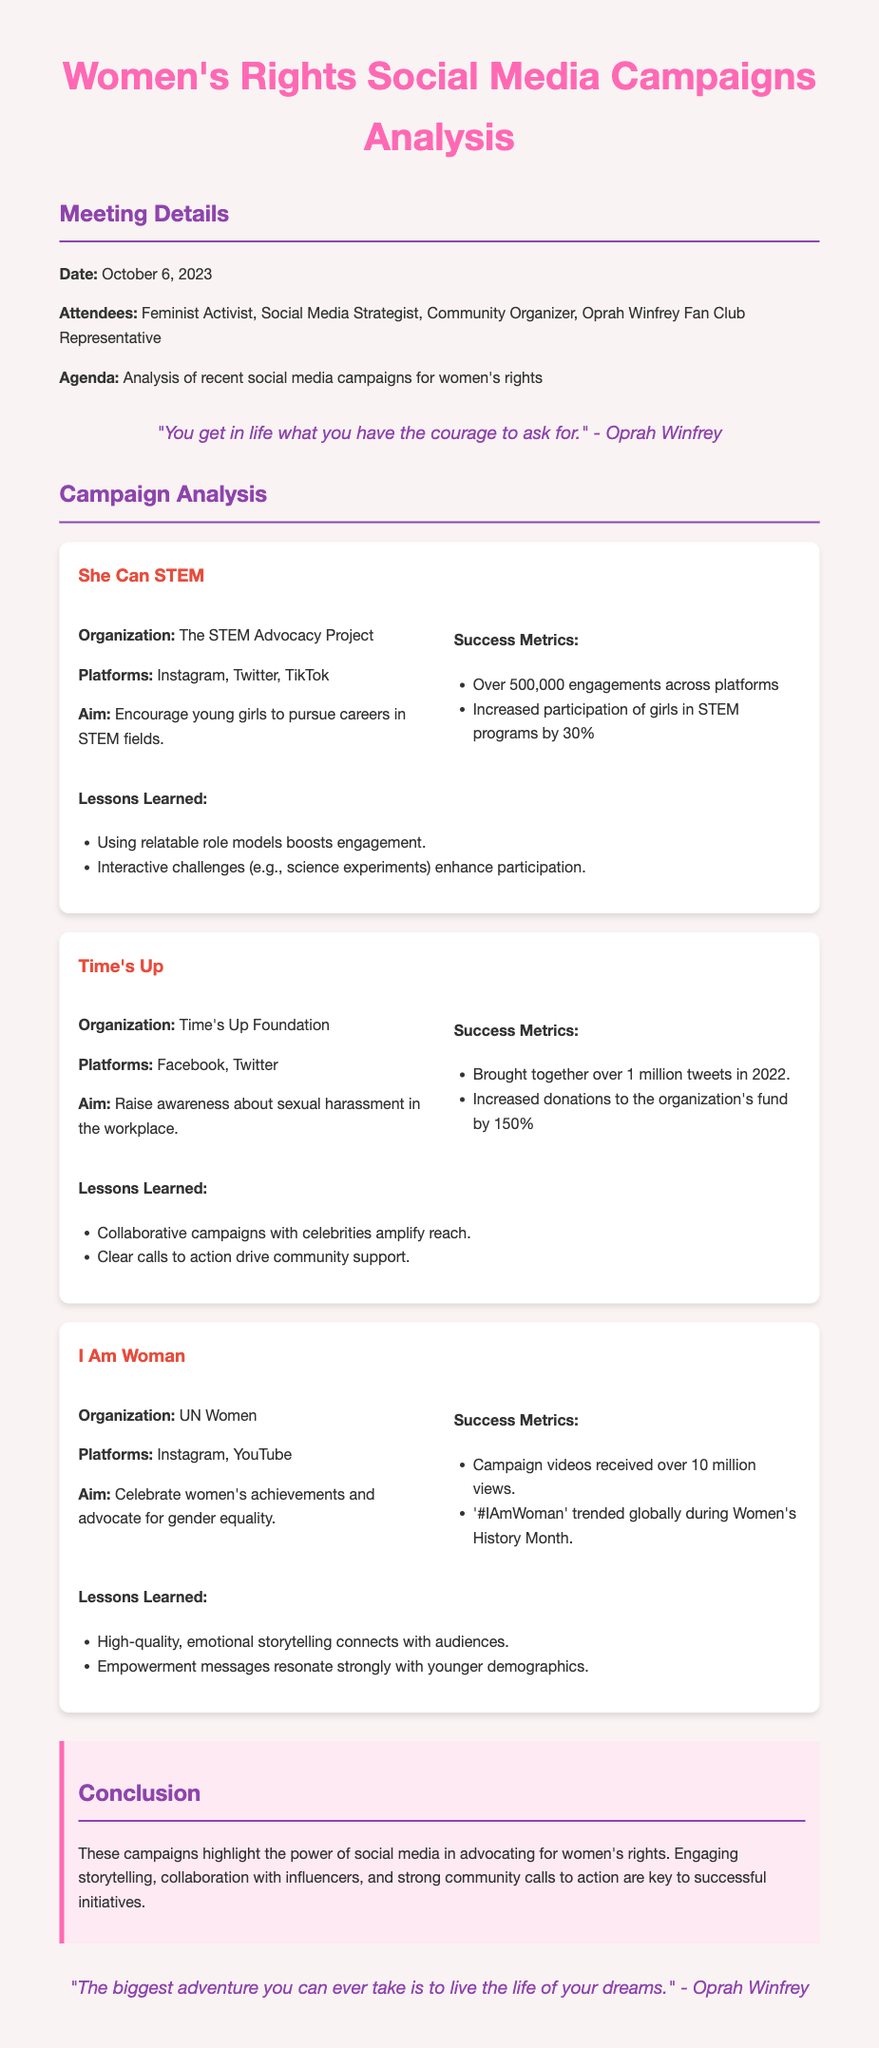What is the date of the meeting? The date of the meeting is specified in the meeting details section.
Answer: October 6, 2023 Who organized the "She Can STEM" campaign? Details about the organization behind the campaign are provided in the campaign analysis section.
Answer: The STEM Advocacy Project How many engagements did the "Time's Up" campaign generate? The success metrics provide quantifiable results for the campaigns.
Answer: Over 1 million tweets What was the aim of the "I Am Woman" campaign? Each campaign's aim is explicitly stated in the respective details section.
Answer: Celebrate women's achievements and advocate for gender equality What lesson was learned from the "She Can STEM" campaign? Lessons learned from each campaign are listed, illustrating key takeaways.
Answer: Using relatable role models boosts engagement Which platforms were used for the "Time's Up" campaign? The platforms where each campaign was active are mentioned in the campaign details.
Answer: Facebook, Twitter What is highlighted as a key to successful initiatives in the conclusion? The conclusion provides a summary of important aspects for success that were discussed in the meeting.
Answer: Engaging storytelling How many views did the campaign videos for "I Am Woman" receive? This information is part of the success metrics outlined for the campaign.
Answer: Over 10 million views 